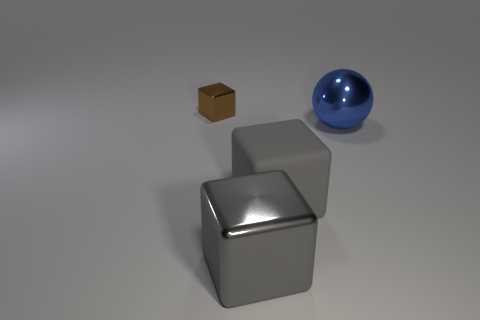Add 1 big metal cubes. How many objects exist? 5 Subtract all balls. How many objects are left? 3 Subtract all blue spheres. Subtract all cubes. How many objects are left? 0 Add 3 large gray rubber cubes. How many large gray rubber cubes are left? 4 Add 4 shiny cubes. How many shiny cubes exist? 6 Subtract 0 purple balls. How many objects are left? 4 